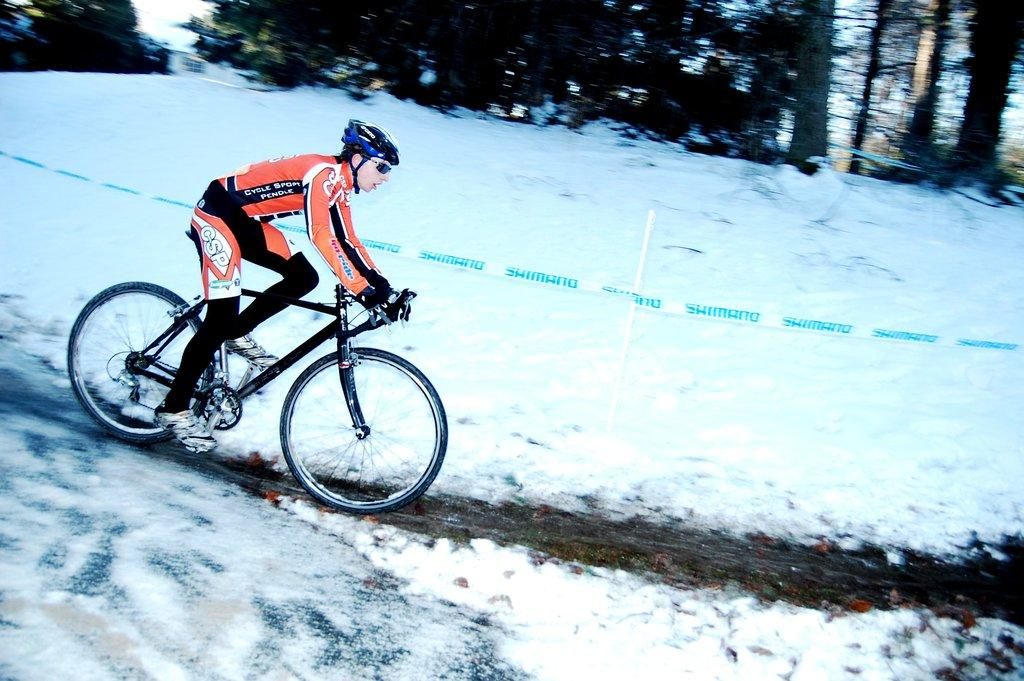Who or what is the main subject in the image? There is a person in the image. What is the person wearing? The person is wearing a helmet. What activity is the person engaged in? The person is riding a bicycle. What is the condition of the ground in the image? The ground has snow on it. What type of vegetation is visible on either side of the ground? There are trees on either side of the ground. How would you describe the sky in the image? The sky is bright in the image. What type of rice can be seen growing in the image? There is no rice visible in the image; it features a person riding a bicycle in a snowy environment with trees and a bright sky. 